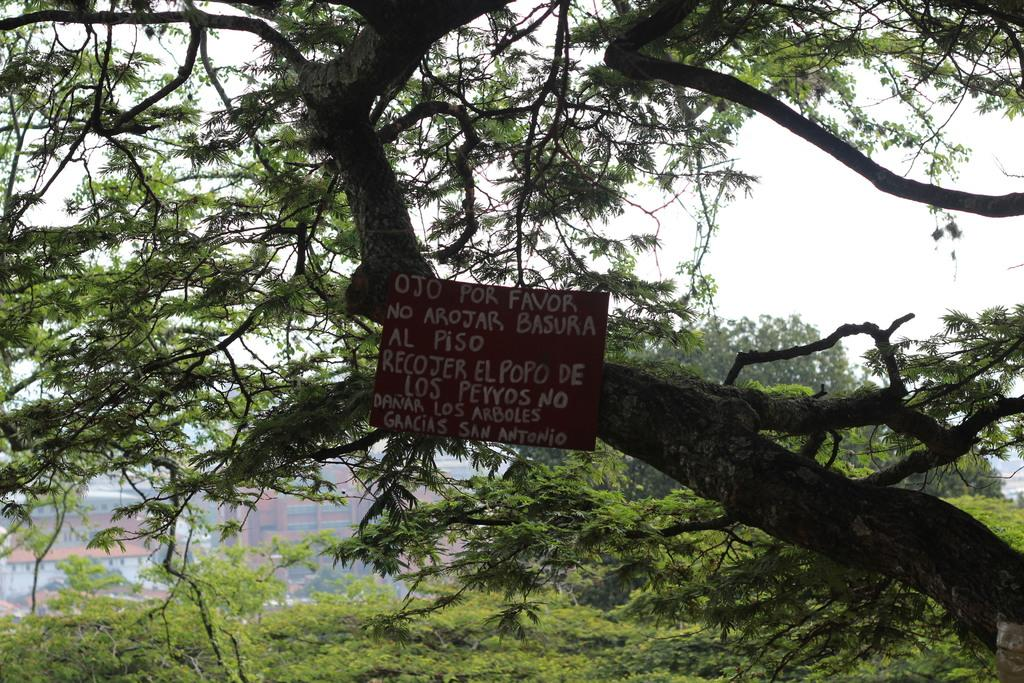What is attached to the tree in the image? There is a board on a tree in the image. How many trees can be seen in the image? There are multiple trees visible in the image. What type of structure can be seen in the image? There is at least one building in the image. What type of guide is present in the image? There is no guide present in the image; it only features a board on a tree, multiple trees, and a building. 